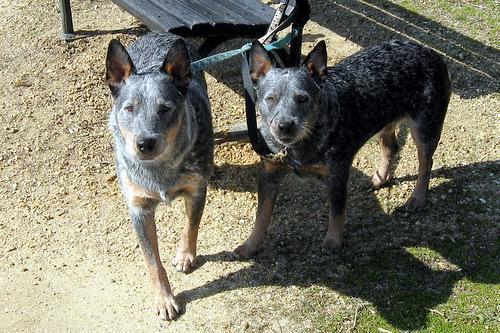What would most likely explain why these dogs look similar?
Select the accurate answer and provide explanation: 'Answer: answer
Rationale: rationale.'
Options: Dog farm, clone, family, optical illusion. Answer: family.
Rationale: The dogs look very similar and are friendly towards each other. 